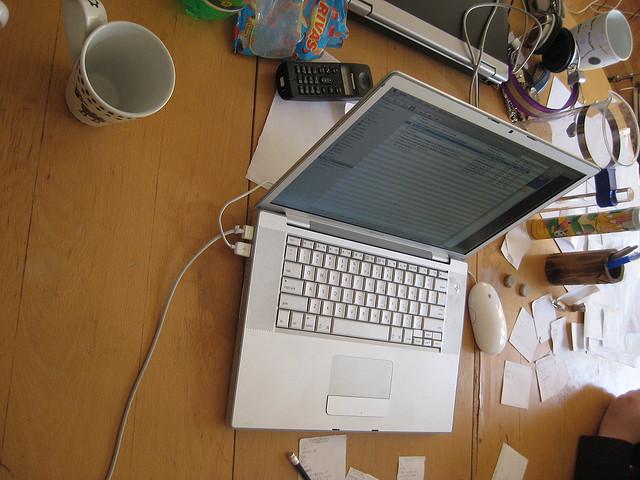Do you think this laptop is beyond repair?
Be succinct. No. Is the table cluttered?
Quick response, please. Yes. Is the laptop open?
Be succinct. Yes. What is in the cup?
Write a very short answer. Nothing. 